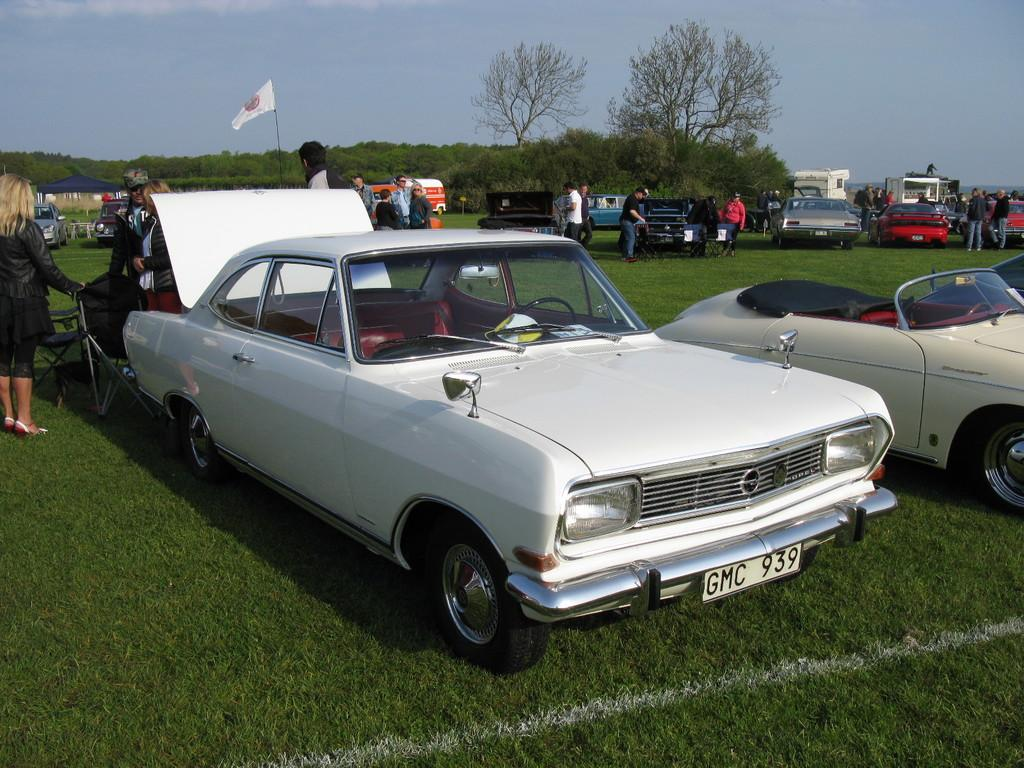What can be seen in the image that is used for transportation? There are vehicles in the image. Where are the people located in the image? There is a group of people on the grass in the image. What is visible in the background of the image? There is a tent, a flag, and trees in the background of the image. What language are the mice speaking in the image? There are no mice present in the image, so it is not possible to determine what language they might be speaking. 